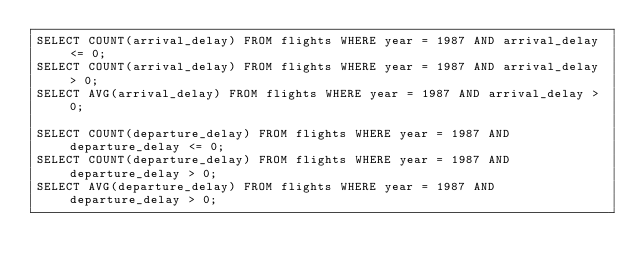Convert code to text. <code><loc_0><loc_0><loc_500><loc_500><_SQL_>SELECT COUNT(arrival_delay) FROM flights WHERE year = 1987 AND arrival_delay <= 0;
SELECT COUNT(arrival_delay) FROM flights WHERE year = 1987 AND arrival_delay > 0;
SELECT AVG(arrival_delay) FROM flights WHERE year = 1987 AND arrival_delay > 0;

SELECT COUNT(departure_delay) FROM flights WHERE year = 1987 AND departure_delay <= 0;
SELECT COUNT(departure_delay) FROM flights WHERE year = 1987 AND departure_delay > 0;
SELECT AVG(departure_delay) FROM flights WHERE year = 1987 AND departure_delay > 0;</code> 